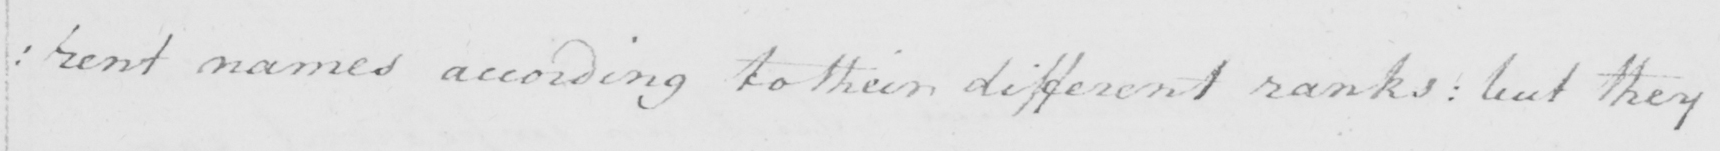What is written in this line of handwriting? : rent names according to their different ranks :  but they 